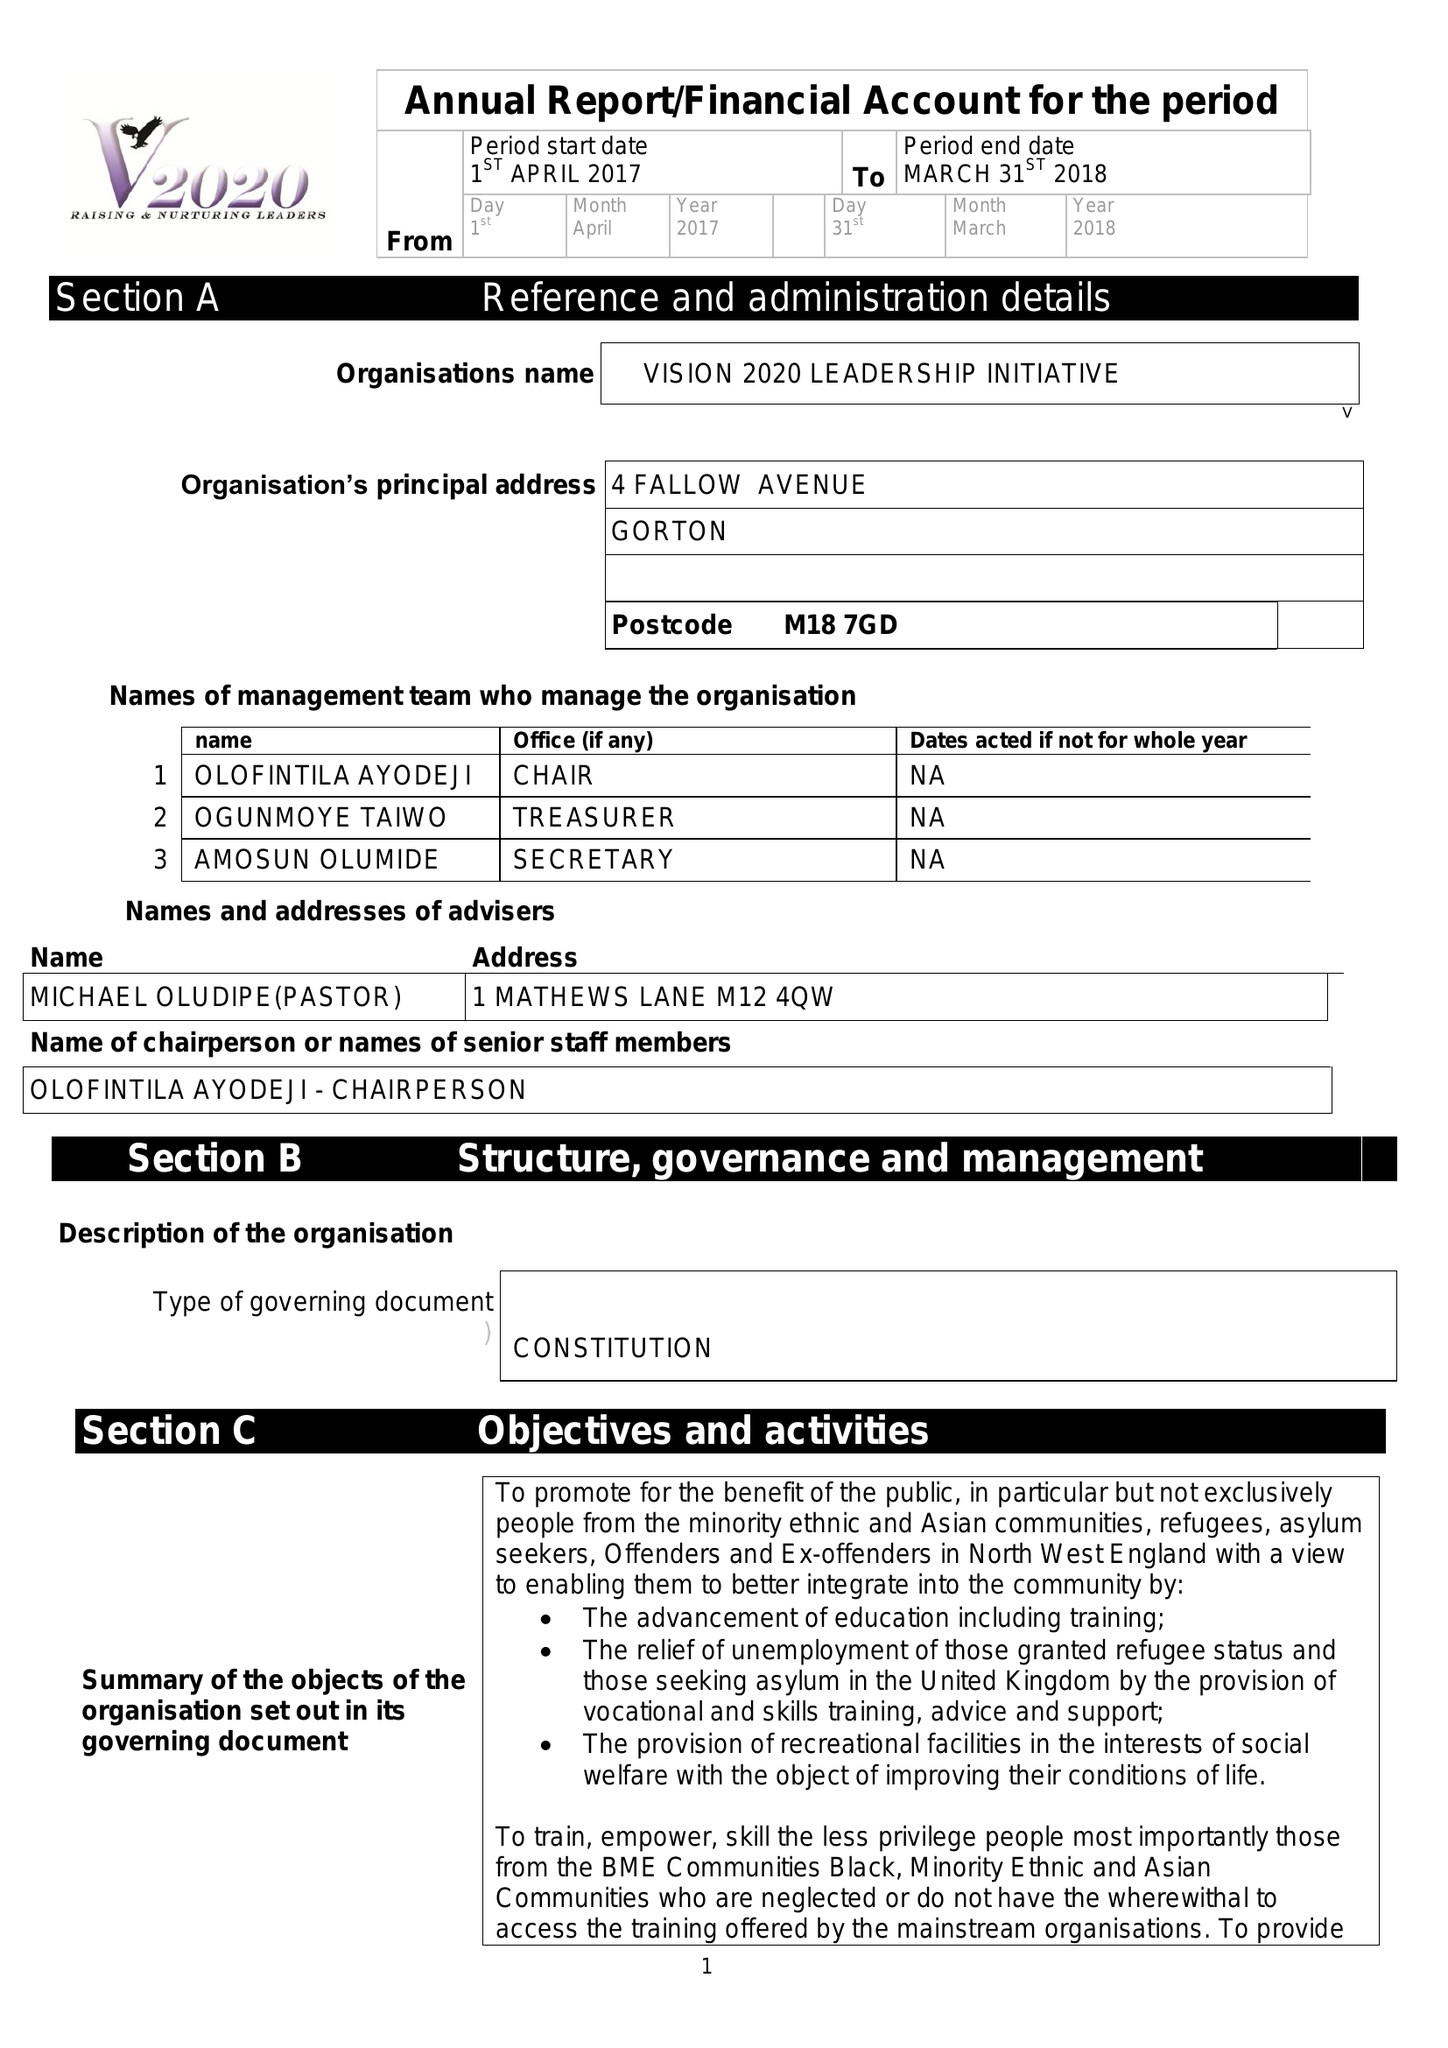What is the value for the address__post_town?
Answer the question using a single word or phrase. MANCHESTER 